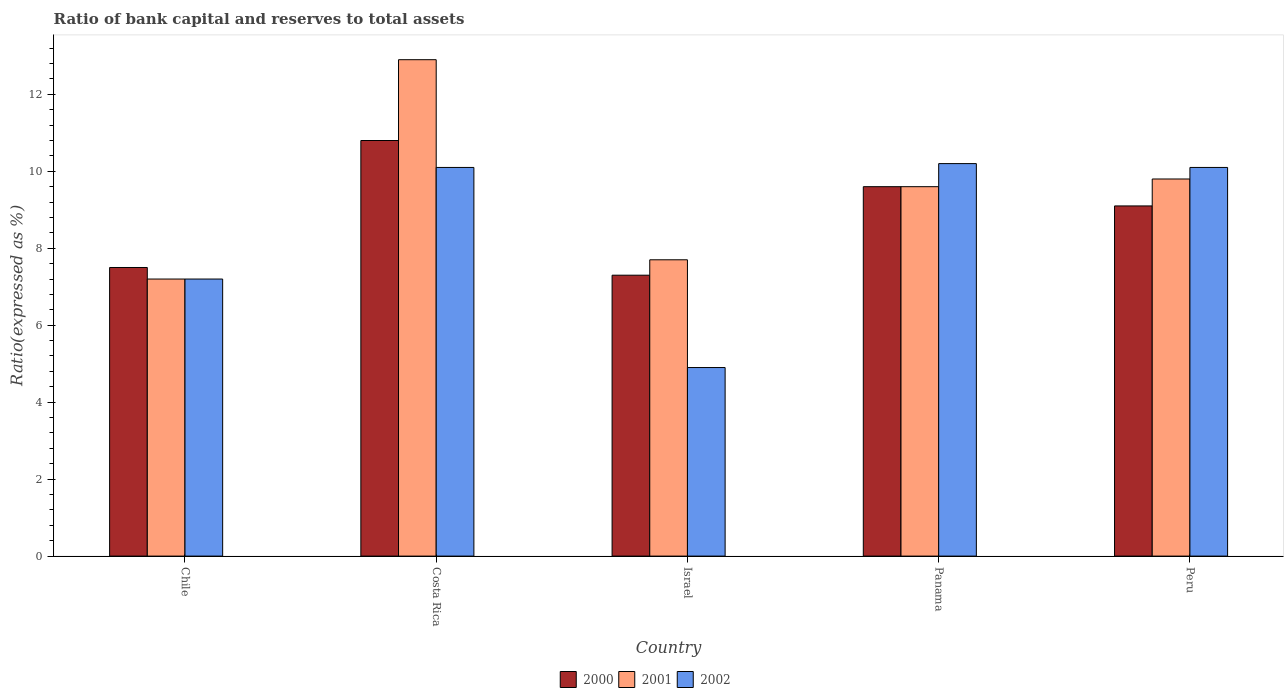How many groups of bars are there?
Provide a short and direct response. 5. In how many cases, is the number of bars for a given country not equal to the number of legend labels?
Offer a terse response. 0. Across all countries, what is the maximum ratio of bank capital and reserves to total assets in 2000?
Make the answer very short. 10.8. What is the total ratio of bank capital and reserves to total assets in 2002 in the graph?
Provide a succinct answer. 42.5. What is the difference between the ratio of bank capital and reserves to total assets in 2000 in Israel and that in Peru?
Keep it short and to the point. -1.8. What is the difference between the ratio of bank capital and reserves to total assets in 2001 in Peru and the ratio of bank capital and reserves to total assets in 2002 in Panama?
Your answer should be compact. -0.4. What is the average ratio of bank capital and reserves to total assets in 2001 per country?
Your response must be concise. 9.44. What is the difference between the ratio of bank capital and reserves to total assets of/in 2002 and ratio of bank capital and reserves to total assets of/in 2001 in Costa Rica?
Provide a succinct answer. -2.8. What is the ratio of the ratio of bank capital and reserves to total assets in 2000 in Costa Rica to that in Panama?
Offer a very short reply. 1.13. Is the difference between the ratio of bank capital and reserves to total assets in 2002 in Chile and Costa Rica greater than the difference between the ratio of bank capital and reserves to total assets in 2001 in Chile and Costa Rica?
Offer a terse response. Yes. What is the difference between the highest and the second highest ratio of bank capital and reserves to total assets in 2001?
Your response must be concise. -3.1. What is the difference between the highest and the lowest ratio of bank capital and reserves to total assets in 2001?
Keep it short and to the point. 5.7. What does the 3rd bar from the left in Israel represents?
Provide a succinct answer. 2002. Is it the case that in every country, the sum of the ratio of bank capital and reserves to total assets in 2001 and ratio of bank capital and reserves to total assets in 2002 is greater than the ratio of bank capital and reserves to total assets in 2000?
Keep it short and to the point. Yes. Are the values on the major ticks of Y-axis written in scientific E-notation?
Your response must be concise. No. Does the graph contain any zero values?
Offer a terse response. No. Does the graph contain grids?
Your answer should be very brief. No. Where does the legend appear in the graph?
Provide a succinct answer. Bottom center. How many legend labels are there?
Give a very brief answer. 3. How are the legend labels stacked?
Ensure brevity in your answer.  Horizontal. What is the title of the graph?
Offer a very short reply. Ratio of bank capital and reserves to total assets. What is the label or title of the Y-axis?
Ensure brevity in your answer.  Ratio(expressed as %). What is the Ratio(expressed as %) of 2000 in Chile?
Give a very brief answer. 7.5. What is the Ratio(expressed as %) in 2001 in Chile?
Keep it short and to the point. 7.2. What is the Ratio(expressed as %) of 2000 in Costa Rica?
Offer a terse response. 10.8. What is the Ratio(expressed as %) of 2000 in Israel?
Your answer should be compact. 7.3. What is the Ratio(expressed as %) in 2002 in Israel?
Give a very brief answer. 4.9. What is the Ratio(expressed as %) in 2002 in Panama?
Provide a succinct answer. 10.2. What is the Ratio(expressed as %) in 2000 in Peru?
Your answer should be very brief. 9.1. What is the Ratio(expressed as %) in 2001 in Peru?
Keep it short and to the point. 9.8. Across all countries, what is the minimum Ratio(expressed as %) of 2001?
Make the answer very short. 7.2. What is the total Ratio(expressed as %) of 2000 in the graph?
Make the answer very short. 44.3. What is the total Ratio(expressed as %) of 2001 in the graph?
Your response must be concise. 47.2. What is the total Ratio(expressed as %) in 2002 in the graph?
Give a very brief answer. 42.5. What is the difference between the Ratio(expressed as %) in 2000 in Chile and that in Costa Rica?
Offer a terse response. -3.3. What is the difference between the Ratio(expressed as %) in 2002 in Chile and that in Costa Rica?
Your answer should be compact. -2.9. What is the difference between the Ratio(expressed as %) in 2000 in Chile and that in Israel?
Ensure brevity in your answer.  0.2. What is the difference between the Ratio(expressed as %) of 2000 in Chile and that in Panama?
Give a very brief answer. -2.1. What is the difference between the Ratio(expressed as %) in 2001 in Chile and that in Panama?
Make the answer very short. -2.4. What is the difference between the Ratio(expressed as %) of 2002 in Costa Rica and that in Israel?
Offer a terse response. 5.2. What is the difference between the Ratio(expressed as %) of 2000 in Costa Rica and that in Panama?
Make the answer very short. 1.2. What is the difference between the Ratio(expressed as %) of 2001 in Costa Rica and that in Panama?
Keep it short and to the point. 3.3. What is the difference between the Ratio(expressed as %) of 2000 in Israel and that in Panama?
Make the answer very short. -2.3. What is the difference between the Ratio(expressed as %) of 2002 in Israel and that in Panama?
Your answer should be compact. -5.3. What is the difference between the Ratio(expressed as %) of 2001 in Israel and that in Peru?
Make the answer very short. -2.1. What is the difference between the Ratio(expressed as %) of 2000 in Chile and the Ratio(expressed as %) of 2001 in Costa Rica?
Your response must be concise. -5.4. What is the difference between the Ratio(expressed as %) of 2000 in Chile and the Ratio(expressed as %) of 2002 in Costa Rica?
Your answer should be very brief. -2.6. What is the difference between the Ratio(expressed as %) of 2000 in Chile and the Ratio(expressed as %) of 2002 in Israel?
Your answer should be compact. 2.6. What is the difference between the Ratio(expressed as %) of 2000 in Chile and the Ratio(expressed as %) of 2001 in Panama?
Your answer should be very brief. -2.1. What is the difference between the Ratio(expressed as %) in 2001 in Chile and the Ratio(expressed as %) in 2002 in Panama?
Make the answer very short. -3. What is the difference between the Ratio(expressed as %) in 2000 in Chile and the Ratio(expressed as %) in 2001 in Peru?
Provide a short and direct response. -2.3. What is the difference between the Ratio(expressed as %) in 2000 in Chile and the Ratio(expressed as %) in 2002 in Peru?
Make the answer very short. -2.6. What is the difference between the Ratio(expressed as %) in 2001 in Chile and the Ratio(expressed as %) in 2002 in Peru?
Provide a succinct answer. -2.9. What is the difference between the Ratio(expressed as %) in 2000 in Costa Rica and the Ratio(expressed as %) in 2001 in Israel?
Provide a succinct answer. 3.1. What is the difference between the Ratio(expressed as %) of 2000 in Costa Rica and the Ratio(expressed as %) of 2002 in Israel?
Provide a short and direct response. 5.9. What is the difference between the Ratio(expressed as %) of 2001 in Costa Rica and the Ratio(expressed as %) of 2002 in Israel?
Keep it short and to the point. 8. What is the difference between the Ratio(expressed as %) in 2000 in Costa Rica and the Ratio(expressed as %) in 2001 in Panama?
Offer a terse response. 1.2. What is the difference between the Ratio(expressed as %) in 2000 in Costa Rica and the Ratio(expressed as %) in 2002 in Panama?
Keep it short and to the point. 0.6. What is the difference between the Ratio(expressed as %) in 2000 in Costa Rica and the Ratio(expressed as %) in 2002 in Peru?
Give a very brief answer. 0.7. What is the difference between the Ratio(expressed as %) in 2001 in Israel and the Ratio(expressed as %) in 2002 in Panama?
Make the answer very short. -2.5. What is the difference between the Ratio(expressed as %) in 2000 in Israel and the Ratio(expressed as %) in 2001 in Peru?
Provide a short and direct response. -2.5. What is the difference between the Ratio(expressed as %) of 2001 in Israel and the Ratio(expressed as %) of 2002 in Peru?
Make the answer very short. -2.4. What is the difference between the Ratio(expressed as %) of 2000 in Panama and the Ratio(expressed as %) of 2001 in Peru?
Offer a very short reply. -0.2. What is the average Ratio(expressed as %) of 2000 per country?
Your answer should be very brief. 8.86. What is the average Ratio(expressed as %) in 2001 per country?
Ensure brevity in your answer.  9.44. What is the difference between the Ratio(expressed as %) in 2000 and Ratio(expressed as %) in 2001 in Costa Rica?
Offer a very short reply. -2.1. What is the difference between the Ratio(expressed as %) of 2000 and Ratio(expressed as %) of 2001 in Israel?
Your answer should be compact. -0.4. What is the difference between the Ratio(expressed as %) of 2000 and Ratio(expressed as %) of 2002 in Israel?
Make the answer very short. 2.4. What is the difference between the Ratio(expressed as %) in 2000 and Ratio(expressed as %) in 2001 in Panama?
Ensure brevity in your answer.  0. What is the difference between the Ratio(expressed as %) of 2000 and Ratio(expressed as %) of 2002 in Panama?
Your answer should be very brief. -0.6. What is the difference between the Ratio(expressed as %) of 2000 and Ratio(expressed as %) of 2001 in Peru?
Offer a very short reply. -0.7. What is the difference between the Ratio(expressed as %) of 2000 and Ratio(expressed as %) of 2002 in Peru?
Keep it short and to the point. -1. What is the ratio of the Ratio(expressed as %) in 2000 in Chile to that in Costa Rica?
Provide a succinct answer. 0.69. What is the ratio of the Ratio(expressed as %) of 2001 in Chile to that in Costa Rica?
Keep it short and to the point. 0.56. What is the ratio of the Ratio(expressed as %) in 2002 in Chile to that in Costa Rica?
Provide a short and direct response. 0.71. What is the ratio of the Ratio(expressed as %) in 2000 in Chile to that in Israel?
Give a very brief answer. 1.03. What is the ratio of the Ratio(expressed as %) of 2001 in Chile to that in Israel?
Your response must be concise. 0.94. What is the ratio of the Ratio(expressed as %) of 2002 in Chile to that in Israel?
Offer a very short reply. 1.47. What is the ratio of the Ratio(expressed as %) in 2000 in Chile to that in Panama?
Offer a terse response. 0.78. What is the ratio of the Ratio(expressed as %) of 2001 in Chile to that in Panama?
Make the answer very short. 0.75. What is the ratio of the Ratio(expressed as %) in 2002 in Chile to that in Panama?
Give a very brief answer. 0.71. What is the ratio of the Ratio(expressed as %) of 2000 in Chile to that in Peru?
Offer a very short reply. 0.82. What is the ratio of the Ratio(expressed as %) of 2001 in Chile to that in Peru?
Your answer should be very brief. 0.73. What is the ratio of the Ratio(expressed as %) of 2002 in Chile to that in Peru?
Your answer should be very brief. 0.71. What is the ratio of the Ratio(expressed as %) in 2000 in Costa Rica to that in Israel?
Provide a short and direct response. 1.48. What is the ratio of the Ratio(expressed as %) of 2001 in Costa Rica to that in Israel?
Provide a short and direct response. 1.68. What is the ratio of the Ratio(expressed as %) of 2002 in Costa Rica to that in Israel?
Ensure brevity in your answer.  2.06. What is the ratio of the Ratio(expressed as %) in 2001 in Costa Rica to that in Panama?
Keep it short and to the point. 1.34. What is the ratio of the Ratio(expressed as %) of 2002 in Costa Rica to that in Panama?
Make the answer very short. 0.99. What is the ratio of the Ratio(expressed as %) in 2000 in Costa Rica to that in Peru?
Offer a very short reply. 1.19. What is the ratio of the Ratio(expressed as %) of 2001 in Costa Rica to that in Peru?
Your answer should be very brief. 1.32. What is the ratio of the Ratio(expressed as %) in 2000 in Israel to that in Panama?
Your response must be concise. 0.76. What is the ratio of the Ratio(expressed as %) of 2001 in Israel to that in Panama?
Provide a succinct answer. 0.8. What is the ratio of the Ratio(expressed as %) of 2002 in Israel to that in Panama?
Keep it short and to the point. 0.48. What is the ratio of the Ratio(expressed as %) of 2000 in Israel to that in Peru?
Give a very brief answer. 0.8. What is the ratio of the Ratio(expressed as %) in 2001 in Israel to that in Peru?
Keep it short and to the point. 0.79. What is the ratio of the Ratio(expressed as %) in 2002 in Israel to that in Peru?
Make the answer very short. 0.49. What is the ratio of the Ratio(expressed as %) of 2000 in Panama to that in Peru?
Provide a short and direct response. 1.05. What is the ratio of the Ratio(expressed as %) in 2001 in Panama to that in Peru?
Make the answer very short. 0.98. What is the ratio of the Ratio(expressed as %) in 2002 in Panama to that in Peru?
Your answer should be very brief. 1.01. What is the difference between the highest and the lowest Ratio(expressed as %) of 2000?
Your response must be concise. 3.5. 